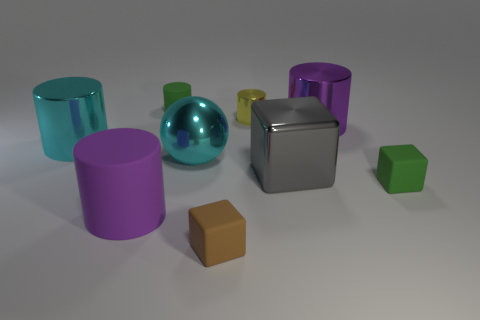Subtract all purple cylinders. How many were subtracted if there are1purple cylinders left? 1 Subtract all gray blocks. How many blocks are left? 2 Subtract all big purple cylinders. How many cylinders are left? 3 Subtract 1 balls. How many balls are left? 0 Subtract all yellow blocks. Subtract all brown cylinders. How many blocks are left? 3 Subtract all gray cylinders. How many brown spheres are left? 0 Subtract all big objects. Subtract all gray cylinders. How many objects are left? 4 Add 2 large cylinders. How many large cylinders are left? 5 Add 6 purple metal objects. How many purple metal objects exist? 7 Add 1 big red balls. How many objects exist? 10 